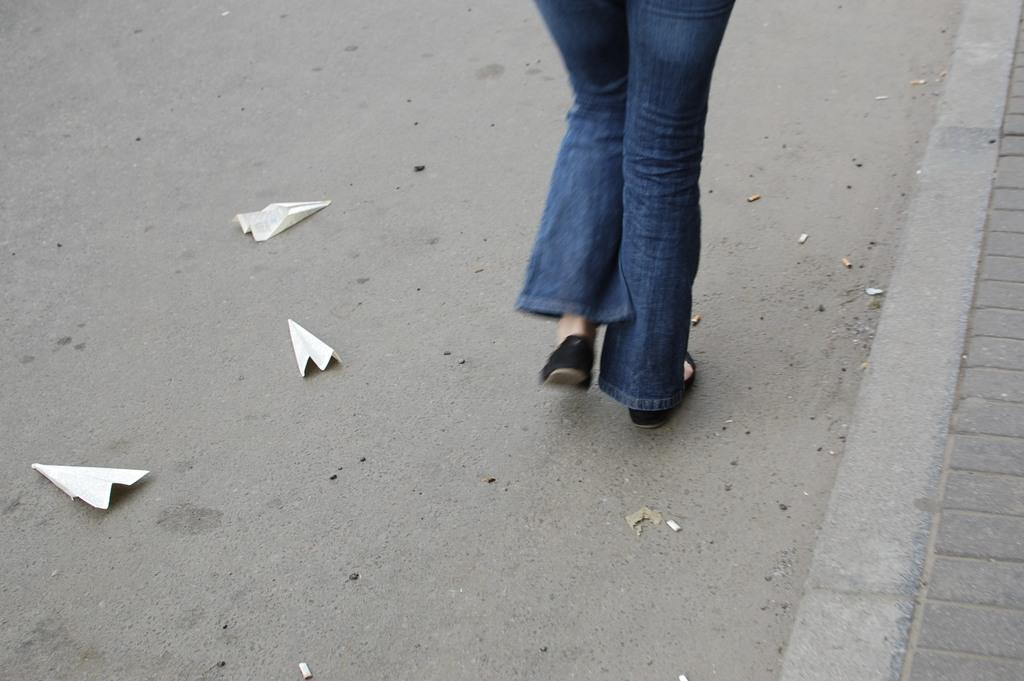What is the main feature of the image? There is a road in the image. What else can be seen on the road? Papers are visible on the road. Whose legs are visible in the image? Human legs are visible in the image. What is located on the right side of the road? There is a footpath on the right side of the image. What type of shoe can be seen on the square in the image? There is no square or shoe present in the image. 